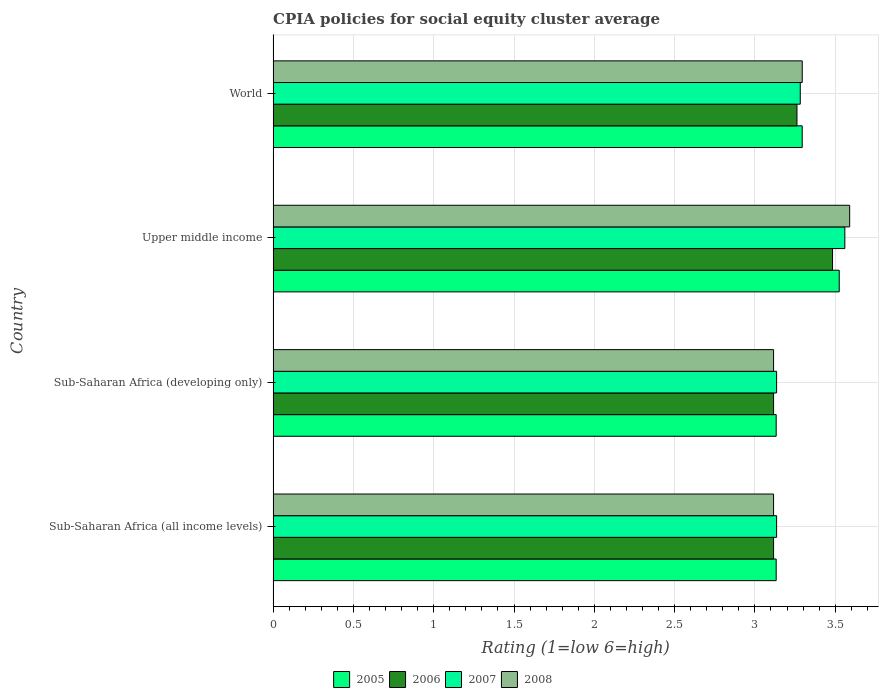How many different coloured bars are there?
Provide a short and direct response. 4. How many bars are there on the 2nd tick from the bottom?
Your answer should be compact. 4. What is the label of the 4th group of bars from the top?
Keep it short and to the point. Sub-Saharan Africa (all income levels). What is the CPIA rating in 2007 in Sub-Saharan Africa (all income levels)?
Your response must be concise. 3.14. Across all countries, what is the maximum CPIA rating in 2006?
Your answer should be very brief. 3.48. Across all countries, what is the minimum CPIA rating in 2006?
Give a very brief answer. 3.12. In which country was the CPIA rating in 2007 maximum?
Make the answer very short. Upper middle income. In which country was the CPIA rating in 2007 minimum?
Your answer should be very brief. Sub-Saharan Africa (all income levels). What is the total CPIA rating in 2005 in the graph?
Provide a short and direct response. 13.08. What is the difference between the CPIA rating in 2005 in Sub-Saharan Africa (all income levels) and that in Upper middle income?
Ensure brevity in your answer.  -0.39. What is the average CPIA rating in 2005 per country?
Keep it short and to the point. 3.27. What is the difference between the CPIA rating in 2007 and CPIA rating in 2005 in Sub-Saharan Africa (all income levels)?
Your answer should be very brief. 0. What is the ratio of the CPIA rating in 2007 in Sub-Saharan Africa (all income levels) to that in Sub-Saharan Africa (developing only)?
Your response must be concise. 1. Is the CPIA rating in 2008 in Sub-Saharan Africa (all income levels) less than that in Upper middle income?
Provide a succinct answer. Yes. Is the difference between the CPIA rating in 2007 in Sub-Saharan Africa (developing only) and Upper middle income greater than the difference between the CPIA rating in 2005 in Sub-Saharan Africa (developing only) and Upper middle income?
Make the answer very short. No. What is the difference between the highest and the second highest CPIA rating in 2008?
Offer a terse response. 0.3. What is the difference between the highest and the lowest CPIA rating in 2006?
Your answer should be very brief. 0.37. Is it the case that in every country, the sum of the CPIA rating in 2005 and CPIA rating in 2007 is greater than the sum of CPIA rating in 2006 and CPIA rating in 2008?
Your answer should be very brief. No. Are all the bars in the graph horizontal?
Offer a very short reply. Yes. What is the difference between two consecutive major ticks on the X-axis?
Ensure brevity in your answer.  0.5. Does the graph contain any zero values?
Offer a very short reply. No. What is the title of the graph?
Your answer should be compact. CPIA policies for social equity cluster average. What is the label or title of the Y-axis?
Provide a succinct answer. Country. What is the Rating (1=low 6=high) in 2005 in Sub-Saharan Africa (all income levels)?
Offer a very short reply. 3.13. What is the Rating (1=low 6=high) in 2006 in Sub-Saharan Africa (all income levels)?
Offer a terse response. 3.12. What is the Rating (1=low 6=high) in 2007 in Sub-Saharan Africa (all income levels)?
Keep it short and to the point. 3.14. What is the Rating (1=low 6=high) in 2008 in Sub-Saharan Africa (all income levels)?
Provide a succinct answer. 3.12. What is the Rating (1=low 6=high) of 2005 in Sub-Saharan Africa (developing only)?
Your answer should be compact. 3.13. What is the Rating (1=low 6=high) in 2006 in Sub-Saharan Africa (developing only)?
Make the answer very short. 3.12. What is the Rating (1=low 6=high) in 2007 in Sub-Saharan Africa (developing only)?
Offer a very short reply. 3.14. What is the Rating (1=low 6=high) of 2008 in Sub-Saharan Africa (developing only)?
Make the answer very short. 3.12. What is the Rating (1=low 6=high) of 2005 in Upper middle income?
Keep it short and to the point. 3.52. What is the Rating (1=low 6=high) in 2006 in Upper middle income?
Give a very brief answer. 3.48. What is the Rating (1=low 6=high) in 2007 in Upper middle income?
Offer a very short reply. 3.56. What is the Rating (1=low 6=high) in 2008 in Upper middle income?
Offer a very short reply. 3.59. What is the Rating (1=low 6=high) of 2005 in World?
Offer a very short reply. 3.29. What is the Rating (1=low 6=high) of 2006 in World?
Make the answer very short. 3.26. What is the Rating (1=low 6=high) of 2007 in World?
Provide a succinct answer. 3.28. What is the Rating (1=low 6=high) of 2008 in World?
Ensure brevity in your answer.  3.29. Across all countries, what is the maximum Rating (1=low 6=high) of 2005?
Offer a terse response. 3.52. Across all countries, what is the maximum Rating (1=low 6=high) in 2006?
Ensure brevity in your answer.  3.48. Across all countries, what is the maximum Rating (1=low 6=high) of 2007?
Make the answer very short. 3.56. Across all countries, what is the maximum Rating (1=low 6=high) of 2008?
Give a very brief answer. 3.59. Across all countries, what is the minimum Rating (1=low 6=high) of 2005?
Provide a short and direct response. 3.13. Across all countries, what is the minimum Rating (1=low 6=high) in 2006?
Ensure brevity in your answer.  3.12. Across all countries, what is the minimum Rating (1=low 6=high) of 2007?
Keep it short and to the point. 3.14. Across all countries, what is the minimum Rating (1=low 6=high) of 2008?
Ensure brevity in your answer.  3.12. What is the total Rating (1=low 6=high) in 2005 in the graph?
Ensure brevity in your answer.  13.08. What is the total Rating (1=low 6=high) in 2006 in the graph?
Your response must be concise. 12.98. What is the total Rating (1=low 6=high) of 2007 in the graph?
Your response must be concise. 13.11. What is the total Rating (1=low 6=high) in 2008 in the graph?
Your answer should be compact. 13.12. What is the difference between the Rating (1=low 6=high) of 2005 in Sub-Saharan Africa (all income levels) and that in Sub-Saharan Africa (developing only)?
Make the answer very short. 0. What is the difference between the Rating (1=low 6=high) in 2006 in Sub-Saharan Africa (all income levels) and that in Sub-Saharan Africa (developing only)?
Provide a short and direct response. 0. What is the difference between the Rating (1=low 6=high) in 2008 in Sub-Saharan Africa (all income levels) and that in Sub-Saharan Africa (developing only)?
Your response must be concise. 0. What is the difference between the Rating (1=low 6=high) of 2005 in Sub-Saharan Africa (all income levels) and that in Upper middle income?
Offer a very short reply. -0.39. What is the difference between the Rating (1=low 6=high) in 2006 in Sub-Saharan Africa (all income levels) and that in Upper middle income?
Offer a very short reply. -0.37. What is the difference between the Rating (1=low 6=high) in 2007 in Sub-Saharan Africa (all income levels) and that in Upper middle income?
Provide a succinct answer. -0.42. What is the difference between the Rating (1=low 6=high) of 2008 in Sub-Saharan Africa (all income levels) and that in Upper middle income?
Provide a succinct answer. -0.47. What is the difference between the Rating (1=low 6=high) of 2005 in Sub-Saharan Africa (all income levels) and that in World?
Provide a short and direct response. -0.16. What is the difference between the Rating (1=low 6=high) of 2006 in Sub-Saharan Africa (all income levels) and that in World?
Your answer should be compact. -0.15. What is the difference between the Rating (1=low 6=high) of 2007 in Sub-Saharan Africa (all income levels) and that in World?
Your answer should be compact. -0.15. What is the difference between the Rating (1=low 6=high) of 2008 in Sub-Saharan Africa (all income levels) and that in World?
Give a very brief answer. -0.18. What is the difference between the Rating (1=low 6=high) of 2005 in Sub-Saharan Africa (developing only) and that in Upper middle income?
Ensure brevity in your answer.  -0.39. What is the difference between the Rating (1=low 6=high) in 2006 in Sub-Saharan Africa (developing only) and that in Upper middle income?
Provide a succinct answer. -0.37. What is the difference between the Rating (1=low 6=high) in 2007 in Sub-Saharan Africa (developing only) and that in Upper middle income?
Keep it short and to the point. -0.42. What is the difference between the Rating (1=low 6=high) in 2008 in Sub-Saharan Africa (developing only) and that in Upper middle income?
Offer a terse response. -0.47. What is the difference between the Rating (1=low 6=high) of 2005 in Sub-Saharan Africa (developing only) and that in World?
Ensure brevity in your answer.  -0.16. What is the difference between the Rating (1=low 6=high) of 2006 in Sub-Saharan Africa (developing only) and that in World?
Offer a very short reply. -0.15. What is the difference between the Rating (1=low 6=high) in 2007 in Sub-Saharan Africa (developing only) and that in World?
Give a very brief answer. -0.15. What is the difference between the Rating (1=low 6=high) in 2008 in Sub-Saharan Africa (developing only) and that in World?
Your answer should be compact. -0.18. What is the difference between the Rating (1=low 6=high) of 2005 in Upper middle income and that in World?
Provide a succinct answer. 0.23. What is the difference between the Rating (1=low 6=high) in 2006 in Upper middle income and that in World?
Your response must be concise. 0.22. What is the difference between the Rating (1=low 6=high) in 2007 in Upper middle income and that in World?
Your answer should be compact. 0.28. What is the difference between the Rating (1=low 6=high) of 2008 in Upper middle income and that in World?
Ensure brevity in your answer.  0.3. What is the difference between the Rating (1=low 6=high) in 2005 in Sub-Saharan Africa (all income levels) and the Rating (1=low 6=high) in 2006 in Sub-Saharan Africa (developing only)?
Offer a very short reply. 0.02. What is the difference between the Rating (1=low 6=high) of 2005 in Sub-Saharan Africa (all income levels) and the Rating (1=low 6=high) of 2007 in Sub-Saharan Africa (developing only)?
Offer a terse response. -0. What is the difference between the Rating (1=low 6=high) of 2005 in Sub-Saharan Africa (all income levels) and the Rating (1=low 6=high) of 2008 in Sub-Saharan Africa (developing only)?
Make the answer very short. 0.02. What is the difference between the Rating (1=low 6=high) in 2006 in Sub-Saharan Africa (all income levels) and the Rating (1=low 6=high) in 2007 in Sub-Saharan Africa (developing only)?
Your answer should be very brief. -0.02. What is the difference between the Rating (1=low 6=high) in 2006 in Sub-Saharan Africa (all income levels) and the Rating (1=low 6=high) in 2008 in Sub-Saharan Africa (developing only)?
Your response must be concise. 0. What is the difference between the Rating (1=low 6=high) of 2007 in Sub-Saharan Africa (all income levels) and the Rating (1=low 6=high) of 2008 in Sub-Saharan Africa (developing only)?
Offer a terse response. 0.02. What is the difference between the Rating (1=low 6=high) in 2005 in Sub-Saharan Africa (all income levels) and the Rating (1=low 6=high) in 2006 in Upper middle income?
Your answer should be very brief. -0.35. What is the difference between the Rating (1=low 6=high) in 2005 in Sub-Saharan Africa (all income levels) and the Rating (1=low 6=high) in 2007 in Upper middle income?
Ensure brevity in your answer.  -0.43. What is the difference between the Rating (1=low 6=high) in 2005 in Sub-Saharan Africa (all income levels) and the Rating (1=low 6=high) in 2008 in Upper middle income?
Provide a succinct answer. -0.46. What is the difference between the Rating (1=low 6=high) in 2006 in Sub-Saharan Africa (all income levels) and the Rating (1=low 6=high) in 2007 in Upper middle income?
Offer a very short reply. -0.44. What is the difference between the Rating (1=low 6=high) of 2006 in Sub-Saharan Africa (all income levels) and the Rating (1=low 6=high) of 2008 in Upper middle income?
Your answer should be very brief. -0.47. What is the difference between the Rating (1=low 6=high) of 2007 in Sub-Saharan Africa (all income levels) and the Rating (1=low 6=high) of 2008 in Upper middle income?
Provide a succinct answer. -0.45. What is the difference between the Rating (1=low 6=high) in 2005 in Sub-Saharan Africa (all income levels) and the Rating (1=low 6=high) in 2006 in World?
Keep it short and to the point. -0.13. What is the difference between the Rating (1=low 6=high) in 2005 in Sub-Saharan Africa (all income levels) and the Rating (1=low 6=high) in 2008 in World?
Offer a terse response. -0.16. What is the difference between the Rating (1=low 6=high) of 2006 in Sub-Saharan Africa (all income levels) and the Rating (1=low 6=high) of 2007 in World?
Your answer should be very brief. -0.17. What is the difference between the Rating (1=low 6=high) of 2006 in Sub-Saharan Africa (all income levels) and the Rating (1=low 6=high) of 2008 in World?
Keep it short and to the point. -0.18. What is the difference between the Rating (1=low 6=high) in 2007 in Sub-Saharan Africa (all income levels) and the Rating (1=low 6=high) in 2008 in World?
Your answer should be compact. -0.16. What is the difference between the Rating (1=low 6=high) of 2005 in Sub-Saharan Africa (developing only) and the Rating (1=low 6=high) of 2006 in Upper middle income?
Provide a succinct answer. -0.35. What is the difference between the Rating (1=low 6=high) in 2005 in Sub-Saharan Africa (developing only) and the Rating (1=low 6=high) in 2007 in Upper middle income?
Keep it short and to the point. -0.43. What is the difference between the Rating (1=low 6=high) in 2005 in Sub-Saharan Africa (developing only) and the Rating (1=low 6=high) in 2008 in Upper middle income?
Keep it short and to the point. -0.46. What is the difference between the Rating (1=low 6=high) of 2006 in Sub-Saharan Africa (developing only) and the Rating (1=low 6=high) of 2007 in Upper middle income?
Make the answer very short. -0.44. What is the difference between the Rating (1=low 6=high) in 2006 in Sub-Saharan Africa (developing only) and the Rating (1=low 6=high) in 2008 in Upper middle income?
Your answer should be very brief. -0.47. What is the difference between the Rating (1=low 6=high) of 2007 in Sub-Saharan Africa (developing only) and the Rating (1=low 6=high) of 2008 in Upper middle income?
Give a very brief answer. -0.45. What is the difference between the Rating (1=low 6=high) in 2005 in Sub-Saharan Africa (developing only) and the Rating (1=low 6=high) in 2006 in World?
Offer a very short reply. -0.13. What is the difference between the Rating (1=low 6=high) in 2005 in Sub-Saharan Africa (developing only) and the Rating (1=low 6=high) in 2008 in World?
Provide a short and direct response. -0.16. What is the difference between the Rating (1=low 6=high) in 2006 in Sub-Saharan Africa (developing only) and the Rating (1=low 6=high) in 2007 in World?
Your answer should be compact. -0.17. What is the difference between the Rating (1=low 6=high) of 2006 in Sub-Saharan Africa (developing only) and the Rating (1=low 6=high) of 2008 in World?
Provide a short and direct response. -0.18. What is the difference between the Rating (1=low 6=high) of 2007 in Sub-Saharan Africa (developing only) and the Rating (1=low 6=high) of 2008 in World?
Make the answer very short. -0.16. What is the difference between the Rating (1=low 6=high) of 2005 in Upper middle income and the Rating (1=low 6=high) of 2006 in World?
Provide a short and direct response. 0.26. What is the difference between the Rating (1=low 6=high) in 2005 in Upper middle income and the Rating (1=low 6=high) in 2007 in World?
Provide a succinct answer. 0.24. What is the difference between the Rating (1=low 6=high) in 2005 in Upper middle income and the Rating (1=low 6=high) in 2008 in World?
Provide a short and direct response. 0.23. What is the difference between the Rating (1=low 6=high) in 2006 in Upper middle income and the Rating (1=low 6=high) in 2007 in World?
Your response must be concise. 0.2. What is the difference between the Rating (1=low 6=high) of 2006 in Upper middle income and the Rating (1=low 6=high) of 2008 in World?
Keep it short and to the point. 0.19. What is the difference between the Rating (1=low 6=high) in 2007 in Upper middle income and the Rating (1=low 6=high) in 2008 in World?
Make the answer very short. 0.27. What is the average Rating (1=low 6=high) of 2005 per country?
Make the answer very short. 3.27. What is the average Rating (1=low 6=high) of 2006 per country?
Keep it short and to the point. 3.24. What is the average Rating (1=low 6=high) of 2007 per country?
Your answer should be compact. 3.28. What is the average Rating (1=low 6=high) of 2008 per country?
Provide a succinct answer. 3.28. What is the difference between the Rating (1=low 6=high) in 2005 and Rating (1=low 6=high) in 2006 in Sub-Saharan Africa (all income levels)?
Offer a very short reply. 0.02. What is the difference between the Rating (1=low 6=high) in 2005 and Rating (1=low 6=high) in 2007 in Sub-Saharan Africa (all income levels)?
Keep it short and to the point. -0. What is the difference between the Rating (1=low 6=high) of 2005 and Rating (1=low 6=high) of 2008 in Sub-Saharan Africa (all income levels)?
Make the answer very short. 0.02. What is the difference between the Rating (1=low 6=high) in 2006 and Rating (1=low 6=high) in 2007 in Sub-Saharan Africa (all income levels)?
Provide a short and direct response. -0.02. What is the difference between the Rating (1=low 6=high) in 2007 and Rating (1=low 6=high) in 2008 in Sub-Saharan Africa (all income levels)?
Keep it short and to the point. 0.02. What is the difference between the Rating (1=low 6=high) in 2005 and Rating (1=low 6=high) in 2006 in Sub-Saharan Africa (developing only)?
Provide a succinct answer. 0.02. What is the difference between the Rating (1=low 6=high) of 2005 and Rating (1=low 6=high) of 2007 in Sub-Saharan Africa (developing only)?
Ensure brevity in your answer.  -0. What is the difference between the Rating (1=low 6=high) of 2005 and Rating (1=low 6=high) of 2008 in Sub-Saharan Africa (developing only)?
Give a very brief answer. 0.02. What is the difference between the Rating (1=low 6=high) in 2006 and Rating (1=low 6=high) in 2007 in Sub-Saharan Africa (developing only)?
Your answer should be very brief. -0.02. What is the difference between the Rating (1=low 6=high) of 2006 and Rating (1=low 6=high) of 2008 in Sub-Saharan Africa (developing only)?
Give a very brief answer. 0. What is the difference between the Rating (1=low 6=high) in 2007 and Rating (1=low 6=high) in 2008 in Sub-Saharan Africa (developing only)?
Offer a terse response. 0.02. What is the difference between the Rating (1=low 6=high) of 2005 and Rating (1=low 6=high) of 2006 in Upper middle income?
Your answer should be compact. 0.04. What is the difference between the Rating (1=low 6=high) in 2005 and Rating (1=low 6=high) in 2007 in Upper middle income?
Offer a terse response. -0.04. What is the difference between the Rating (1=low 6=high) of 2005 and Rating (1=low 6=high) of 2008 in Upper middle income?
Ensure brevity in your answer.  -0.07. What is the difference between the Rating (1=low 6=high) of 2006 and Rating (1=low 6=high) of 2007 in Upper middle income?
Offer a very short reply. -0.08. What is the difference between the Rating (1=low 6=high) in 2006 and Rating (1=low 6=high) in 2008 in Upper middle income?
Provide a short and direct response. -0.11. What is the difference between the Rating (1=low 6=high) in 2007 and Rating (1=low 6=high) in 2008 in Upper middle income?
Provide a short and direct response. -0.03. What is the difference between the Rating (1=low 6=high) of 2005 and Rating (1=low 6=high) of 2006 in World?
Provide a short and direct response. 0.03. What is the difference between the Rating (1=low 6=high) of 2005 and Rating (1=low 6=high) of 2007 in World?
Your answer should be very brief. 0.01. What is the difference between the Rating (1=low 6=high) of 2005 and Rating (1=low 6=high) of 2008 in World?
Your answer should be very brief. -0. What is the difference between the Rating (1=low 6=high) of 2006 and Rating (1=low 6=high) of 2007 in World?
Ensure brevity in your answer.  -0.02. What is the difference between the Rating (1=low 6=high) in 2006 and Rating (1=low 6=high) in 2008 in World?
Offer a terse response. -0.03. What is the difference between the Rating (1=low 6=high) in 2007 and Rating (1=low 6=high) in 2008 in World?
Your response must be concise. -0.01. What is the ratio of the Rating (1=low 6=high) of 2006 in Sub-Saharan Africa (all income levels) to that in Sub-Saharan Africa (developing only)?
Your answer should be very brief. 1. What is the ratio of the Rating (1=low 6=high) of 2005 in Sub-Saharan Africa (all income levels) to that in Upper middle income?
Provide a succinct answer. 0.89. What is the ratio of the Rating (1=low 6=high) of 2006 in Sub-Saharan Africa (all income levels) to that in Upper middle income?
Give a very brief answer. 0.89. What is the ratio of the Rating (1=low 6=high) in 2007 in Sub-Saharan Africa (all income levels) to that in Upper middle income?
Give a very brief answer. 0.88. What is the ratio of the Rating (1=low 6=high) in 2008 in Sub-Saharan Africa (all income levels) to that in Upper middle income?
Give a very brief answer. 0.87. What is the ratio of the Rating (1=low 6=high) of 2005 in Sub-Saharan Africa (all income levels) to that in World?
Offer a terse response. 0.95. What is the ratio of the Rating (1=low 6=high) of 2006 in Sub-Saharan Africa (all income levels) to that in World?
Provide a short and direct response. 0.96. What is the ratio of the Rating (1=low 6=high) in 2007 in Sub-Saharan Africa (all income levels) to that in World?
Provide a short and direct response. 0.96. What is the ratio of the Rating (1=low 6=high) in 2008 in Sub-Saharan Africa (all income levels) to that in World?
Provide a short and direct response. 0.95. What is the ratio of the Rating (1=low 6=high) in 2005 in Sub-Saharan Africa (developing only) to that in Upper middle income?
Make the answer very short. 0.89. What is the ratio of the Rating (1=low 6=high) in 2006 in Sub-Saharan Africa (developing only) to that in Upper middle income?
Make the answer very short. 0.89. What is the ratio of the Rating (1=low 6=high) of 2007 in Sub-Saharan Africa (developing only) to that in Upper middle income?
Make the answer very short. 0.88. What is the ratio of the Rating (1=low 6=high) of 2008 in Sub-Saharan Africa (developing only) to that in Upper middle income?
Make the answer very short. 0.87. What is the ratio of the Rating (1=low 6=high) of 2005 in Sub-Saharan Africa (developing only) to that in World?
Keep it short and to the point. 0.95. What is the ratio of the Rating (1=low 6=high) of 2006 in Sub-Saharan Africa (developing only) to that in World?
Give a very brief answer. 0.96. What is the ratio of the Rating (1=low 6=high) of 2007 in Sub-Saharan Africa (developing only) to that in World?
Offer a very short reply. 0.96. What is the ratio of the Rating (1=low 6=high) in 2008 in Sub-Saharan Africa (developing only) to that in World?
Your response must be concise. 0.95. What is the ratio of the Rating (1=low 6=high) in 2005 in Upper middle income to that in World?
Offer a terse response. 1.07. What is the ratio of the Rating (1=low 6=high) in 2006 in Upper middle income to that in World?
Give a very brief answer. 1.07. What is the ratio of the Rating (1=low 6=high) of 2007 in Upper middle income to that in World?
Provide a succinct answer. 1.08. What is the ratio of the Rating (1=low 6=high) in 2008 in Upper middle income to that in World?
Provide a succinct answer. 1.09. What is the difference between the highest and the second highest Rating (1=low 6=high) of 2005?
Provide a succinct answer. 0.23. What is the difference between the highest and the second highest Rating (1=low 6=high) in 2006?
Keep it short and to the point. 0.22. What is the difference between the highest and the second highest Rating (1=low 6=high) of 2007?
Your answer should be compact. 0.28. What is the difference between the highest and the second highest Rating (1=low 6=high) in 2008?
Offer a very short reply. 0.3. What is the difference between the highest and the lowest Rating (1=low 6=high) in 2005?
Offer a terse response. 0.39. What is the difference between the highest and the lowest Rating (1=low 6=high) of 2006?
Give a very brief answer. 0.37. What is the difference between the highest and the lowest Rating (1=low 6=high) in 2007?
Your answer should be compact. 0.42. What is the difference between the highest and the lowest Rating (1=low 6=high) in 2008?
Give a very brief answer. 0.47. 